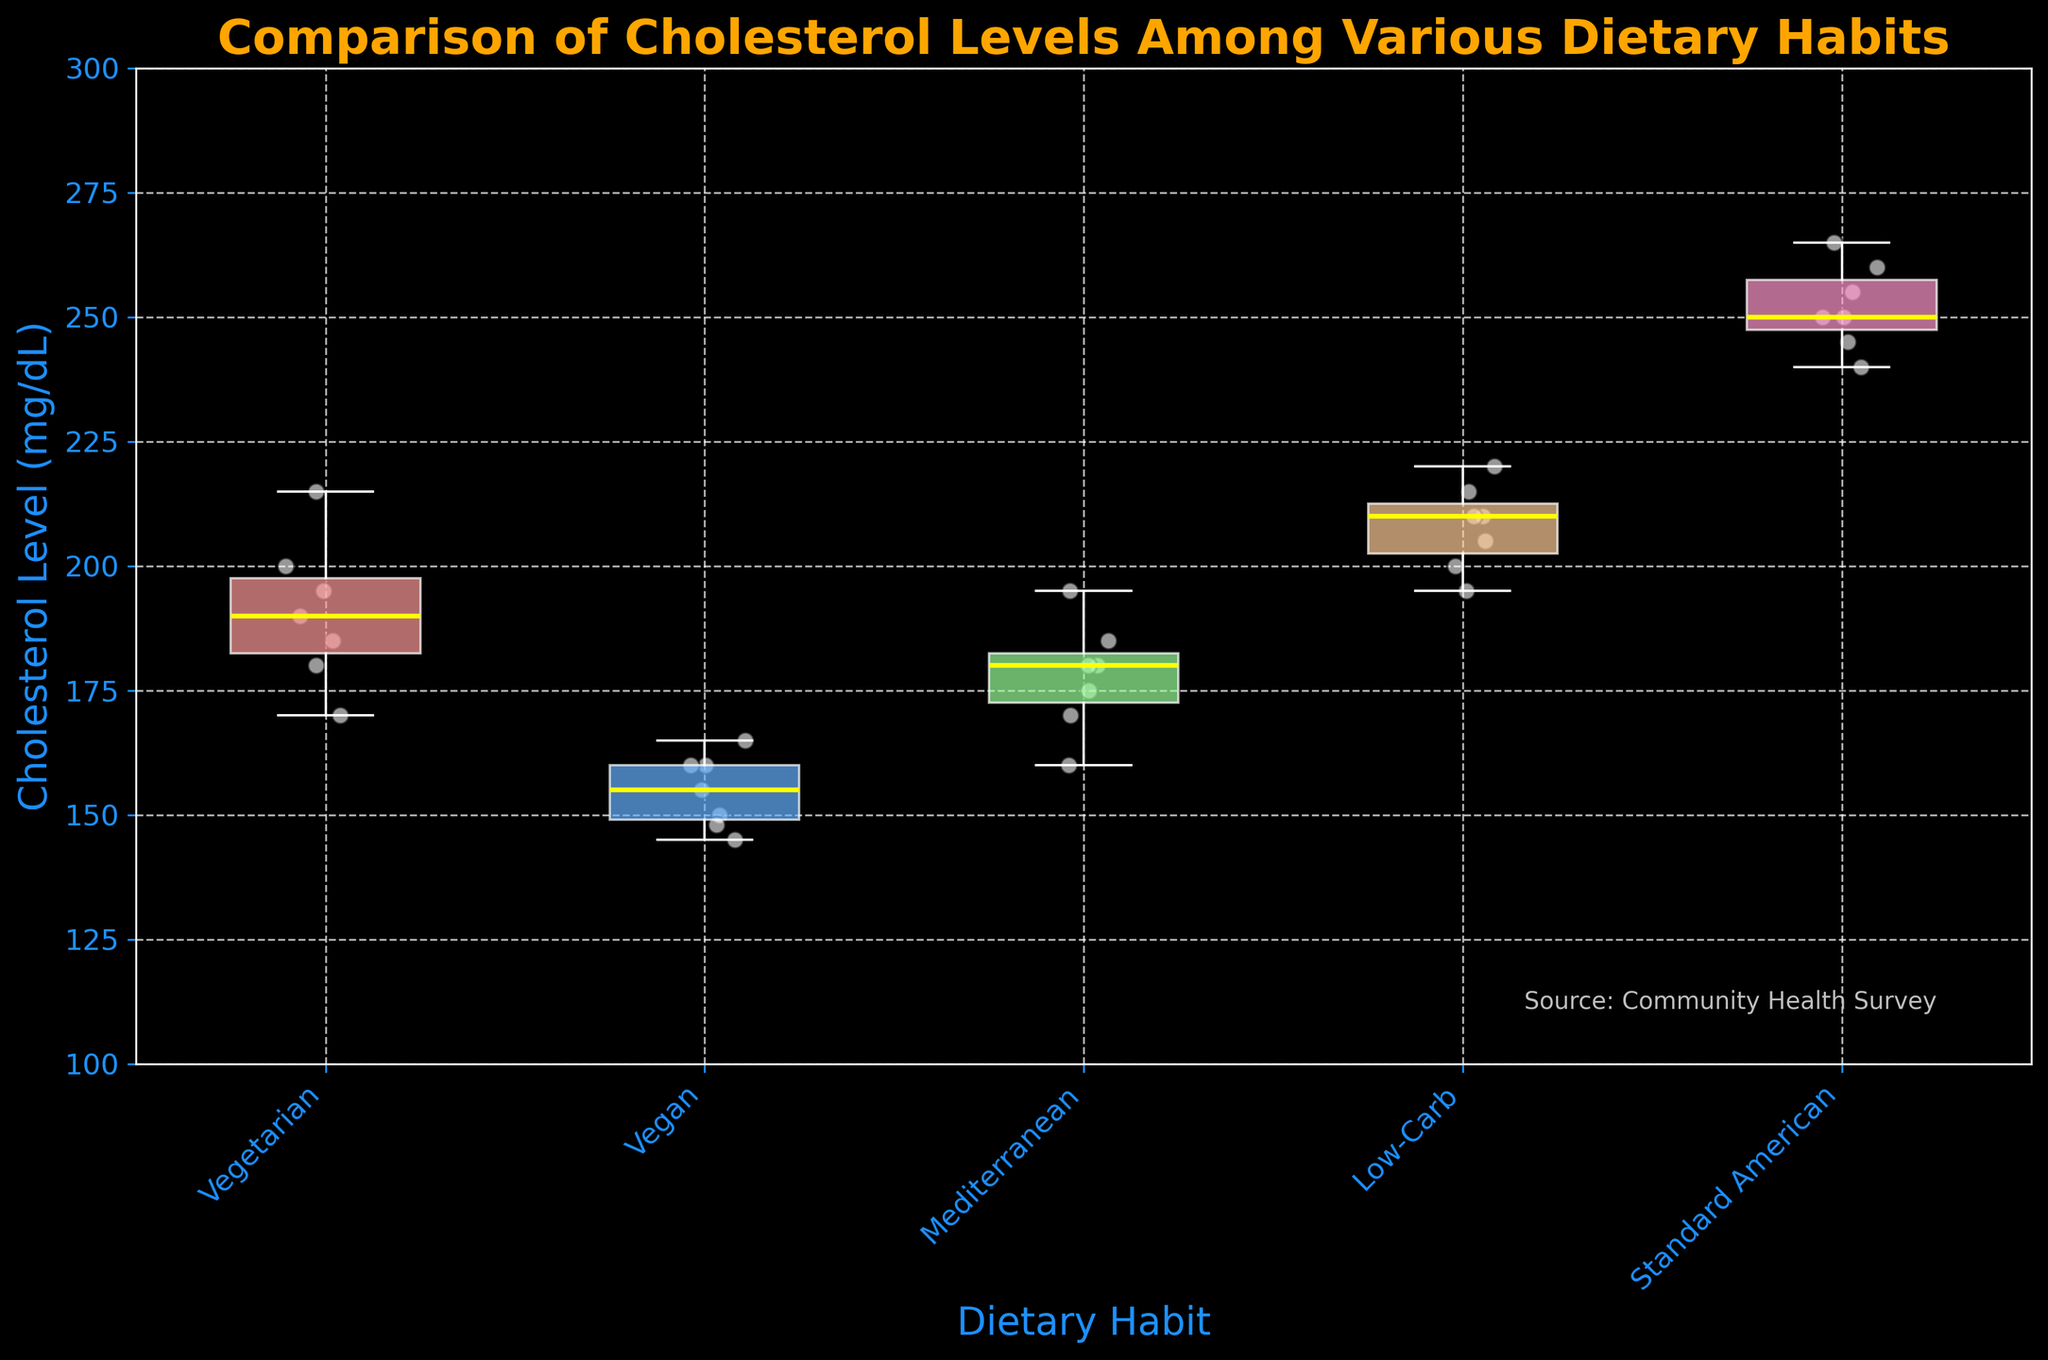What is the title of the plot? The title is always displayed at the top of the plot. It provides the primary context or the purpose of the visualization.
Answer: Comparison of Cholesterol Levels Among Various Dietary Habits What dietary habit shows the highest cholesterol levels? By examining the box plots and scatter points, the group with the highest values will be identified. The Standard American diet's box plot and scatter points reach up to 265 mg/dL.
Answer: Standard American Which dietary habit has the lowest median cholesterol level? The median in a box plot is indicated by the line inside the box. The Vegan diet's box has the lowest median yellow line compared to others.
Answer: Vegan Which dietary habit shows the widest range of cholesterol levels? The range in a box plot is the distance between the minimum and maximum values represented by the ends of the whiskers. The wider the whiskers, the wider the range. The Standard American diet shows the widest whiskers.
Answer: Standard American What is the approximate median cholesterol level for the Low-Carb diet? The median is depicted by the yellow line inside the box for the Low-Carb group, roughly around 205 mg/dL.
Answer: 205 mg/dL Which dietary habit has the most data points? The number of data points can be determined by counting the scatter points for each diet. Each dietary habit has 7 data points as seen from the scatter points.
Answer: All diet groups have 7 points each How does the cholesterol level for the Mediterranean diet compare to the Vegan diet? By comparing the positions of the box plots, the Mediterranean diet has higher cluster points and a higher median than the Vegan diet.
Answer: Mediterranean has higher levels Is the cholesterol level for the Vegetarian diet generally higher or lower than the Mediterranean diet? Observing the overlap and position of the box plots, the Vegetarian diet has higher box and scatter cluster points compared to Mediterranean.
Answer: Higher Which dietary habit shows the least variability in cholesterol levels? Variability is indicated by the spread of the box plot and whiskers. The Vegan diet has the smallest spread, indicating the least variability.
Answer: Vegan 